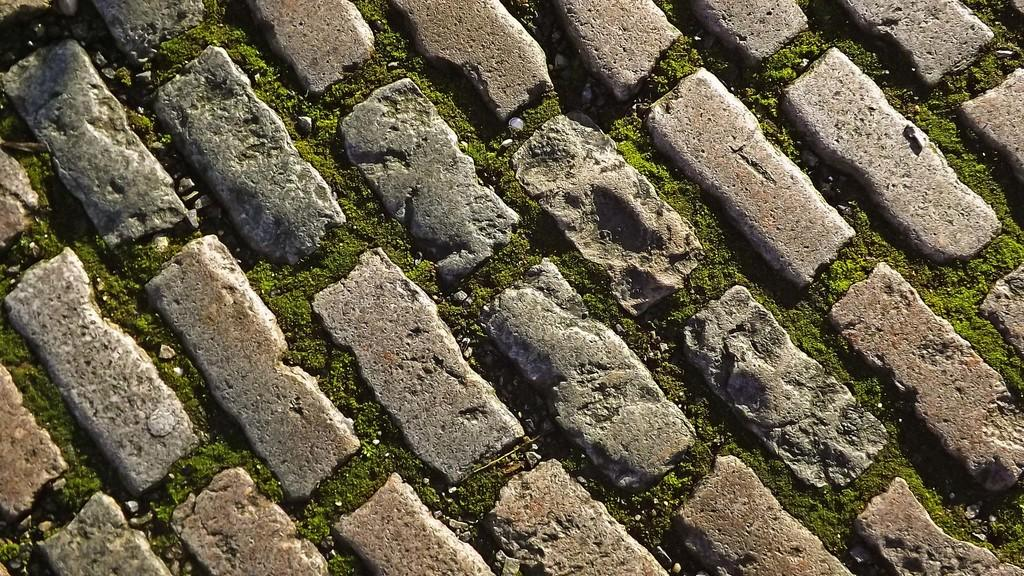What type of vegetation is present in the image? There is grass in the image. What type of surface is depicted in the image? There are cobblestones and small stones in the image, which might depict a pavement. Can you see a pickle lying on the grass in the image? No, there is no pickle present in the image. Is there a goat or monkey visible in the image? No, there are no animals, such as goats or monkeys, present in the image. 